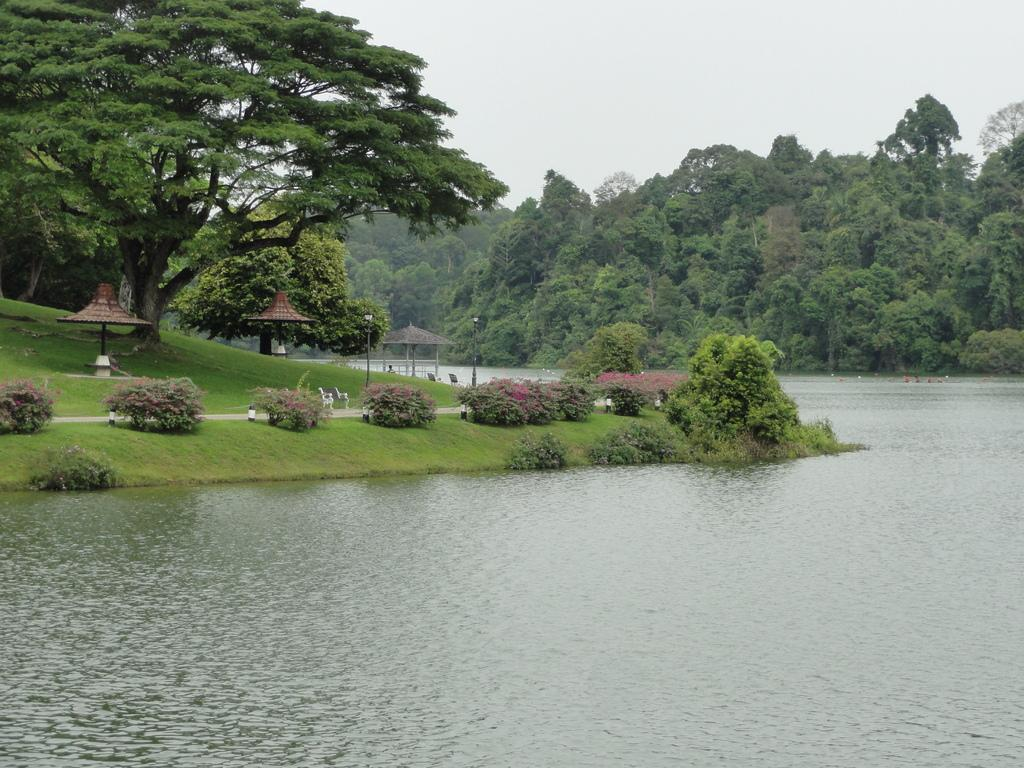What can be seen in the image that is related to water? There is water visible in the image. What type of vegetation is present in the image? There is grass, plants, and trees in the image. What type of man-made structure can be seen in the image? There is a road in the image. Are there any seating areas in the image? Yes, there are benches in the image. What is visible in the background of the image? The sky is visible in the background of the image. Can you tell me how many times the trees in the image have burned? There is no indication in the image that the trees have ever burned, so it cannot be determined from the picture. 